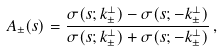<formula> <loc_0><loc_0><loc_500><loc_500>A _ { \pm } ( { s } ) = \frac { \sigma ( { s } ; { k } _ { \pm } ^ { \bot } ) - \sigma ( { s } ; - { k } _ { \pm } ^ { \bot } ) } { \sigma ( { s } ; { k } _ { \pm } ^ { \bot } ) + \sigma ( { s } ; - { k } _ { \pm } ^ { \bot } ) } \, ,</formula> 